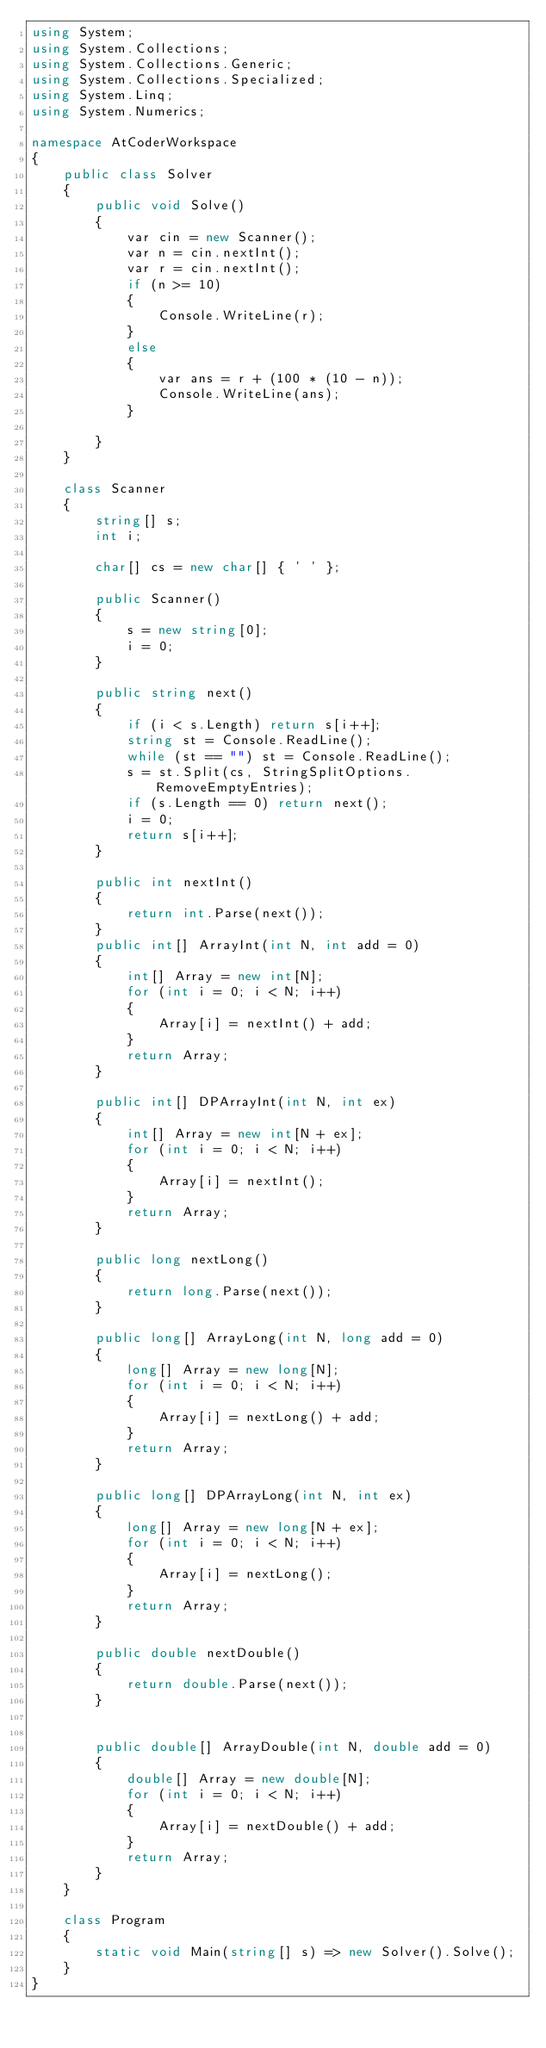<code> <loc_0><loc_0><loc_500><loc_500><_C#_>using System;
using System.Collections;
using System.Collections.Generic;
using System.Collections.Specialized;
using System.Linq;
using System.Numerics;

namespace AtCoderWorkspace
{
    public class Solver
    {
        public void Solve()
        {
            var cin = new Scanner();
            var n = cin.nextInt();
            var r = cin.nextInt();
            if (n >= 10)
            {
                Console.WriteLine(r);
            }
            else
            {
                var ans = r + (100 * (10 - n));
                Console.WriteLine(ans);
            }
            
        }
    }

    class Scanner
    {
        string[] s;
        int i;

        char[] cs = new char[] { ' ' };

        public Scanner()
        {
            s = new string[0];
            i = 0;
        }

        public string next()
        {
            if (i < s.Length) return s[i++];
            string st = Console.ReadLine();
            while (st == "") st = Console.ReadLine();
            s = st.Split(cs, StringSplitOptions.RemoveEmptyEntries);
            if (s.Length == 0) return next();
            i = 0;
            return s[i++];
        }

        public int nextInt()
        {
            return int.Parse(next());
        }
        public int[] ArrayInt(int N, int add = 0)
        {
            int[] Array = new int[N];
            for (int i = 0; i < N; i++)
            {
                Array[i] = nextInt() + add;
            }
            return Array;
        }

        public int[] DPArrayInt(int N, int ex)
        {
            int[] Array = new int[N + ex];
            for (int i = 0; i < N; i++)
            {
                Array[i] = nextInt();
            }
            return Array;
        }

        public long nextLong()
        {
            return long.Parse(next());
        }

        public long[] ArrayLong(int N, long add = 0)
        {
            long[] Array = new long[N];
            for (int i = 0; i < N; i++)
            {
                Array[i] = nextLong() + add;
            }
            return Array;
        }

        public long[] DPArrayLong(int N, int ex)
        {
            long[] Array = new long[N + ex];
            for (int i = 0; i < N; i++)
            {
                Array[i] = nextLong();
            }
            return Array;
        }

        public double nextDouble()
        {
            return double.Parse(next());
        }


        public double[] ArrayDouble(int N, double add = 0)
        {
            double[] Array = new double[N];
            for (int i = 0; i < N; i++)
            {
                Array[i] = nextDouble() + add;
            }
            return Array;
        }
    }

    class Program
    {
        static void Main(string[] s) => new Solver().Solve();
    }
}
</code> 